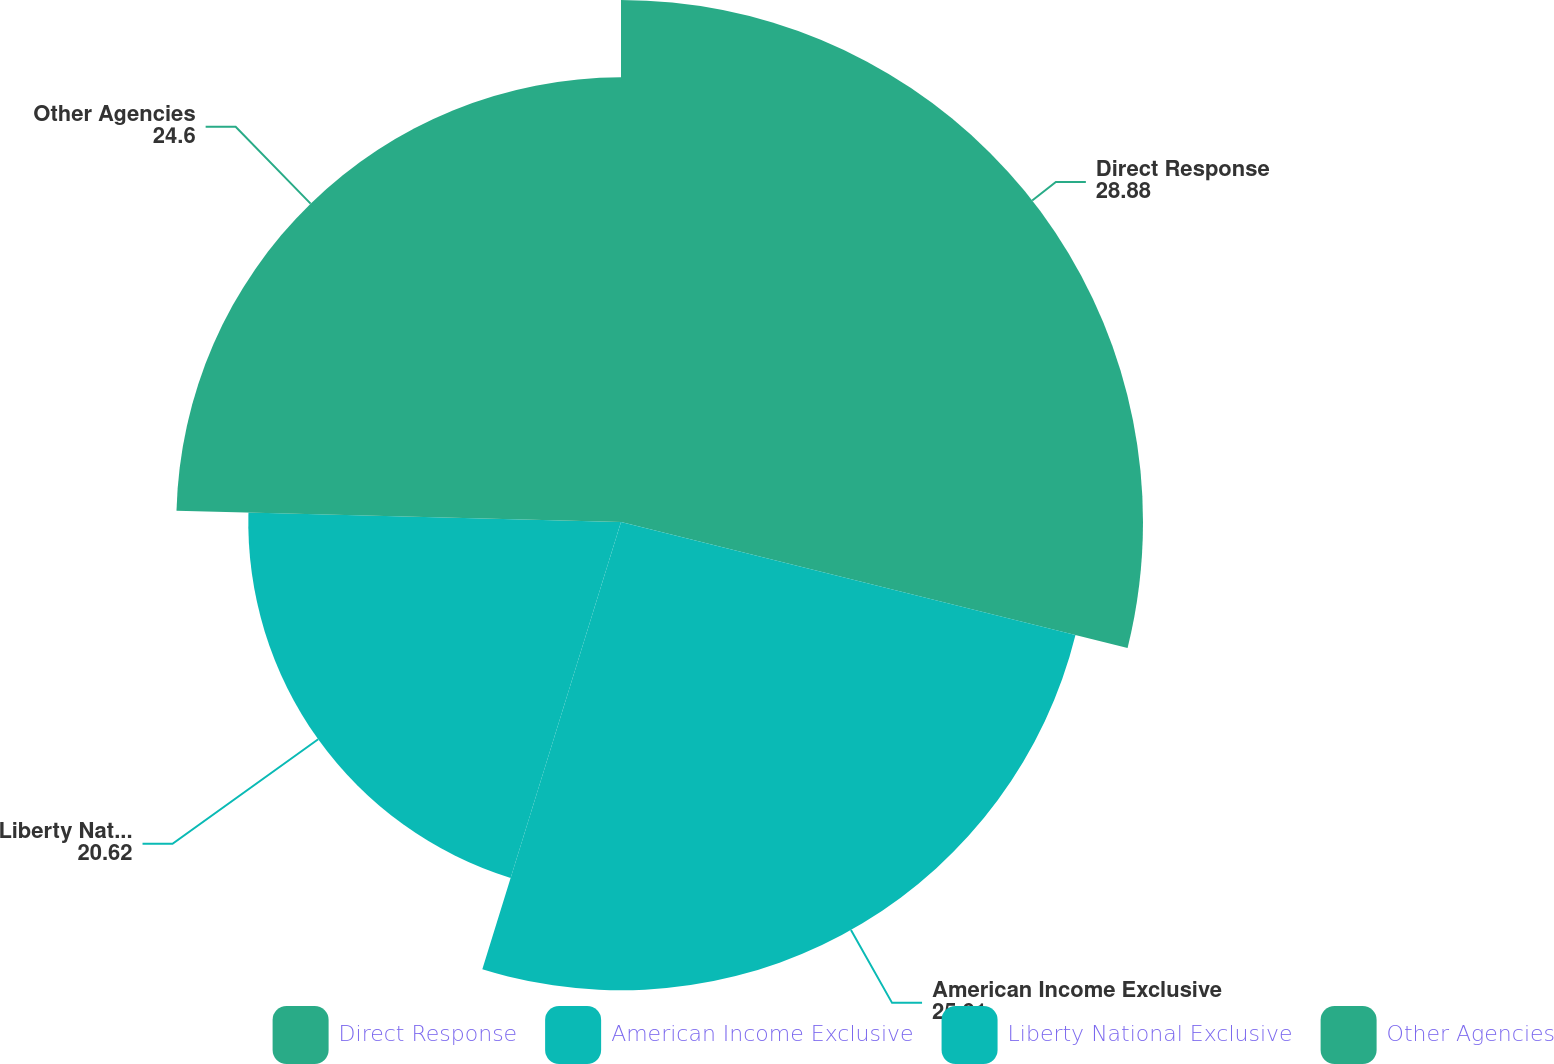<chart> <loc_0><loc_0><loc_500><loc_500><pie_chart><fcel>Direct Response<fcel>American Income Exclusive<fcel>Liberty National Exclusive<fcel>Other Agencies<nl><fcel>28.88%<fcel>25.91%<fcel>20.62%<fcel>24.6%<nl></chart> 